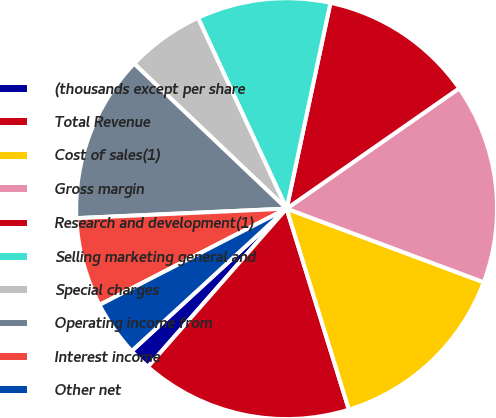Convert chart. <chart><loc_0><loc_0><loc_500><loc_500><pie_chart><fcel>(thousands except per share<fcel>Total Revenue<fcel>Cost of sales(1)<fcel>Gross margin<fcel>Research and development(1)<fcel>Selling marketing general and<fcel>Special charges<fcel>Operating income from<fcel>Interest income<fcel>Other net<nl><fcel>1.71%<fcel>16.24%<fcel>14.53%<fcel>15.38%<fcel>11.97%<fcel>10.26%<fcel>5.98%<fcel>12.82%<fcel>6.84%<fcel>4.27%<nl></chart> 